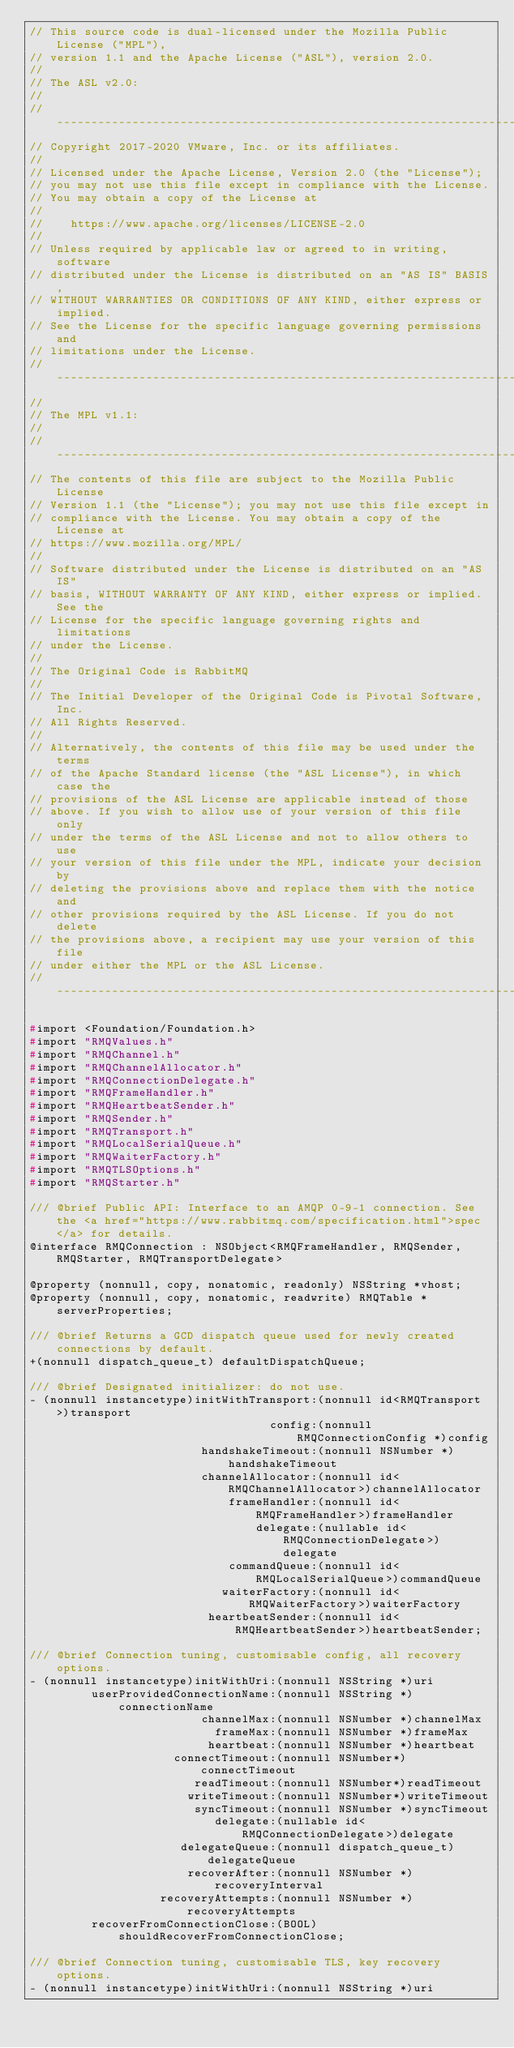Convert code to text. <code><loc_0><loc_0><loc_500><loc_500><_C_>// This source code is dual-licensed under the Mozilla Public License ("MPL"),
// version 1.1 and the Apache License ("ASL"), version 2.0.
//
// The ASL v2.0:
//
// ---------------------------------------------------------------------------
// Copyright 2017-2020 VMware, Inc. or its affiliates.
//
// Licensed under the Apache License, Version 2.0 (the "License");
// you may not use this file except in compliance with the License.
// You may obtain a copy of the License at
//
//    https://www.apache.org/licenses/LICENSE-2.0
//
// Unless required by applicable law or agreed to in writing, software
// distributed under the License is distributed on an "AS IS" BASIS,
// WITHOUT WARRANTIES OR CONDITIONS OF ANY KIND, either express or implied.
// See the License for the specific language governing permissions and
// limitations under the License.
// ---------------------------------------------------------------------------
//
// The MPL v1.1:
//
// ---------------------------------------------------------------------------
// The contents of this file are subject to the Mozilla Public License
// Version 1.1 (the "License"); you may not use this file except in
// compliance with the License. You may obtain a copy of the License at
// https://www.mozilla.org/MPL/
//
// Software distributed under the License is distributed on an "AS IS"
// basis, WITHOUT WARRANTY OF ANY KIND, either express or implied. See the
// License for the specific language governing rights and limitations
// under the License.
//
// The Original Code is RabbitMQ
//
// The Initial Developer of the Original Code is Pivotal Software, Inc.
// All Rights Reserved.
//
// Alternatively, the contents of this file may be used under the terms
// of the Apache Standard license (the "ASL License"), in which case the
// provisions of the ASL License are applicable instead of those
// above. If you wish to allow use of your version of this file only
// under the terms of the ASL License and not to allow others to use
// your version of this file under the MPL, indicate your decision by
// deleting the provisions above and replace them with the notice and
// other provisions required by the ASL License. If you do not delete
// the provisions above, a recipient may use your version of this file
// under either the MPL or the ASL License.
// ---------------------------------------------------------------------------

#import <Foundation/Foundation.h>
#import "RMQValues.h"
#import "RMQChannel.h"
#import "RMQChannelAllocator.h"
#import "RMQConnectionDelegate.h"
#import "RMQFrameHandler.h"
#import "RMQHeartbeatSender.h"
#import "RMQSender.h"
#import "RMQTransport.h"
#import "RMQLocalSerialQueue.h"
#import "RMQWaiterFactory.h"
#import "RMQTLSOptions.h"
#import "RMQStarter.h"

/// @brief Public API: Interface to an AMQP 0-9-1 connection. See the <a href="https://www.rabbitmq.com/specification.html">spec</a> for details.
@interface RMQConnection : NSObject<RMQFrameHandler, RMQSender, RMQStarter, RMQTransportDelegate>

@property (nonnull, copy, nonatomic, readonly) NSString *vhost;
@property (nonnull, copy, nonatomic, readwrite) RMQTable *serverProperties;

/// @brief Returns a GCD dispatch queue used for newly created connections by default.
+(nonnull dispatch_queue_t) defaultDispatchQueue;

/// @brief Designated initializer: do not use.
- (nonnull instancetype)initWithTransport:(nonnull id<RMQTransport>)transport
                                   config:(nonnull RMQConnectionConfig *)config
                         handshakeTimeout:(nonnull NSNumber *)handshakeTimeout
                         channelAllocator:(nonnull id<RMQChannelAllocator>)channelAllocator
                             frameHandler:(nonnull id<RMQFrameHandler>)frameHandler
                                 delegate:(nullable id<RMQConnectionDelegate>)delegate
                             commandQueue:(nonnull id<RMQLocalSerialQueue>)commandQueue
                            waiterFactory:(nonnull id<RMQWaiterFactory>)waiterFactory
                          heartbeatSender:(nonnull id<RMQHeartbeatSender>)heartbeatSender;

/// @brief Connection tuning, customisable config, all recovery options.
- (nonnull instancetype)initWithUri:(nonnull NSString *)uri
         userProvidedConnectionName:(nonnull NSString *)connectionName
                         channelMax:(nonnull NSNumber *)channelMax
                           frameMax:(nonnull NSNumber *)frameMax
                          heartbeat:(nonnull NSNumber *)heartbeat
                     connectTimeout:(nonnull NSNumber*)connectTimeout
                        readTimeout:(nonnull NSNumber*)readTimeout
                       writeTimeout:(nonnull NSNumber*)writeTimeout
                        syncTimeout:(nonnull NSNumber *)syncTimeout
                           delegate:(nullable id<RMQConnectionDelegate>)delegate
                      delegateQueue:(nonnull dispatch_queue_t)delegateQueue
                       recoverAfter:(nonnull NSNumber *)recoveryInterval
                   recoveryAttempts:(nonnull NSNumber *)recoveryAttempts
         recoverFromConnectionClose:(BOOL)shouldRecoverFromConnectionClose;

/// @brief Connection tuning, customisable TLS, key recovery options.
- (nonnull instancetype)initWithUri:(nonnull NSString *)uri</code> 